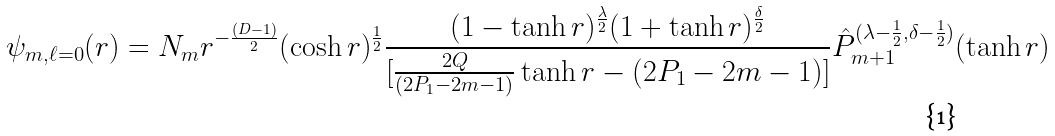Convert formula to latex. <formula><loc_0><loc_0><loc_500><loc_500>\psi _ { m , \ell = 0 } ( r ) = N _ { m } r ^ { - \frac { ( D - 1 ) } { 2 } } ( \cosh { r } ) ^ { \frac { 1 } { 2 } } \frac { ( 1 - \tanh { r } ) ^ { \frac { \lambda } { 2 } } ( 1 + \tanh { r } ) ^ { \frac { \delta } { 2 } } } { [ \frac { 2 Q } { ( 2 P _ { 1 } - 2 m - 1 ) } \tanh { r } - ( 2 P _ { 1 } - 2 m - 1 ) ] } \hat { P } _ { m + 1 } ^ { ( \lambda - \frac { 1 } { 2 } , \delta - \frac { 1 } { 2 } ) } ( \tanh { r } )</formula> 